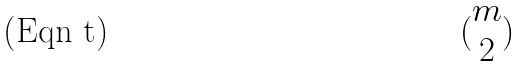Convert formula to latex. <formula><loc_0><loc_0><loc_500><loc_500>( \begin{matrix} m \\ 2 \end{matrix} )</formula> 